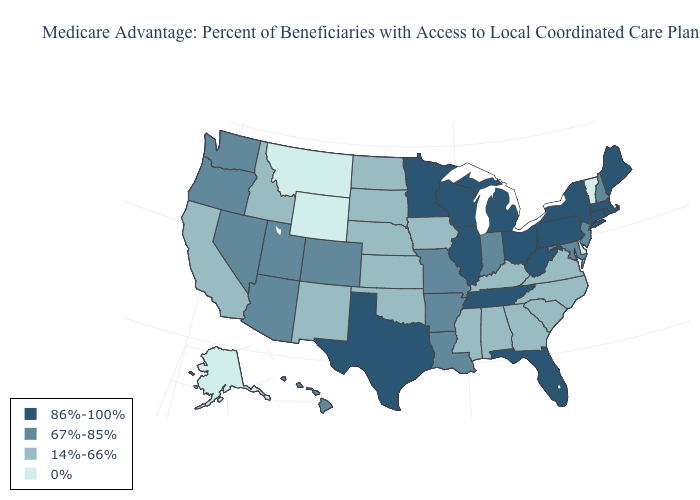Does Montana have the lowest value in the USA?
Answer briefly. Yes. Name the states that have a value in the range 86%-100%?
Answer briefly. Connecticut, Florida, Illinois, Massachusetts, Maine, Michigan, Minnesota, New York, Ohio, Pennsylvania, Rhode Island, Tennessee, Texas, Wisconsin, West Virginia. Which states have the highest value in the USA?
Short answer required. Connecticut, Florida, Illinois, Massachusetts, Maine, Michigan, Minnesota, New York, Ohio, Pennsylvania, Rhode Island, Tennessee, Texas, Wisconsin, West Virginia. What is the lowest value in the West?
Keep it brief. 0%. What is the lowest value in states that border Arizona?
Keep it brief. 14%-66%. Which states have the highest value in the USA?
Give a very brief answer. Connecticut, Florida, Illinois, Massachusetts, Maine, Michigan, Minnesota, New York, Ohio, Pennsylvania, Rhode Island, Tennessee, Texas, Wisconsin, West Virginia. Does Pennsylvania have the highest value in the USA?
Be succinct. Yes. Does the first symbol in the legend represent the smallest category?
Quick response, please. No. What is the lowest value in states that border Washington?
Short answer required. 14%-66%. What is the value of Kentucky?
Write a very short answer. 14%-66%. Does Delaware have the highest value in the South?
Concise answer only. No. Name the states that have a value in the range 86%-100%?
Answer briefly. Connecticut, Florida, Illinois, Massachusetts, Maine, Michigan, Minnesota, New York, Ohio, Pennsylvania, Rhode Island, Tennessee, Texas, Wisconsin, West Virginia. What is the lowest value in states that border Wisconsin?
Quick response, please. 14%-66%. Does Nevada have a lower value than Ohio?
Quick response, please. Yes. What is the value of Nevada?
Answer briefly. 67%-85%. 